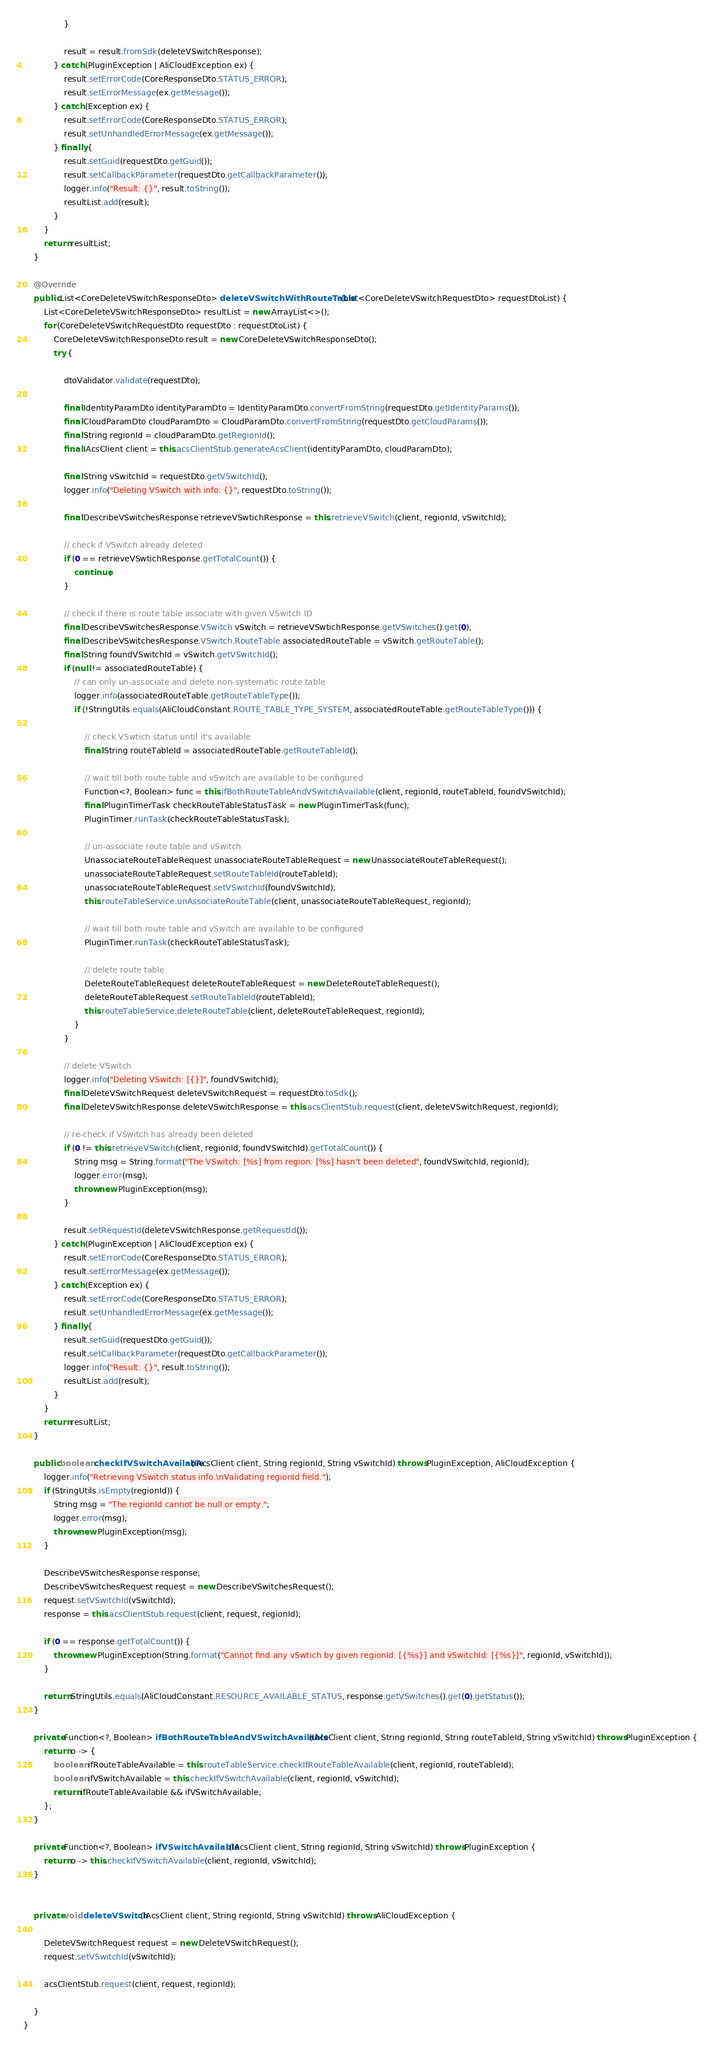<code> <loc_0><loc_0><loc_500><loc_500><_Java_>                }

                result = result.fromSdk(deleteVSwitchResponse);
            } catch (PluginException | AliCloudException ex) {
                result.setErrorCode(CoreResponseDto.STATUS_ERROR);
                result.setErrorMessage(ex.getMessage());
            } catch (Exception ex) {
                result.setErrorCode(CoreResponseDto.STATUS_ERROR);
                result.setUnhandledErrorMessage(ex.getMessage());
            } finally {
                result.setGuid(requestDto.getGuid());
                result.setCallbackParameter(requestDto.getCallbackParameter());
                logger.info("Result: {}", result.toString());
                resultList.add(result);
            }
        }
        return resultList;
    }

    @Override
    public List<CoreDeleteVSwitchResponseDto> deleteVSwitchWithRouteTable(List<CoreDeleteVSwitchRequestDto> requestDtoList) {
        List<CoreDeleteVSwitchResponseDto> resultList = new ArrayList<>();
        for (CoreDeleteVSwitchRequestDto requestDto : requestDtoList) {
            CoreDeleteVSwitchResponseDto result = new CoreDeleteVSwitchResponseDto();
            try {

                dtoValidator.validate(requestDto);

                final IdentityParamDto identityParamDto = IdentityParamDto.convertFromString(requestDto.getIdentityParams());
                final CloudParamDto cloudParamDto = CloudParamDto.convertFromString(requestDto.getCloudParams());
                final String regionId = cloudParamDto.getRegionId();
                final IAcsClient client = this.acsClientStub.generateAcsClient(identityParamDto, cloudParamDto);

                final String vSwitchId = requestDto.getVSwitchId();
                logger.info("Deleting VSwitch with info: {}", requestDto.toString());

                final DescribeVSwitchesResponse retrieveVSwtichResponse = this.retrieveVSwitch(client, regionId, vSwitchId);

                // check if VSwitch already deleted
                if (0 == retrieveVSwtichResponse.getTotalCount()) {
                    continue;
                }

                // check if there is route table associate with given VSwitch ID
                final DescribeVSwitchesResponse.VSwitch vSwitch = retrieveVSwtichResponse.getVSwitches().get(0);
                final DescribeVSwitchesResponse.VSwitch.RouteTable associatedRouteTable = vSwitch.getRouteTable();
                final String foundVSwitchId = vSwitch.getVSwitchId();
                if (null != associatedRouteTable) {
                    // can only un-associate and delete non-systematic route table
                    logger.info(associatedRouteTable.getRouteTableType());
                    if (!StringUtils.equals(AliCloudConstant.ROUTE_TABLE_TYPE_SYSTEM, associatedRouteTable.getRouteTableType())) {

                        // check VSwtich status until it's available
                        final String routeTableId = associatedRouteTable.getRouteTableId();

                        // wait till both route table and vSwitch are available to be configured
                        Function<?, Boolean> func = this.ifBothRouteTableAndVSwitchAvailable(client, regionId, routeTableId, foundVSwitchId);
                        final PluginTimerTask checkRouteTableStatusTask = new PluginTimerTask(func);
                        PluginTimer.runTask(checkRouteTableStatusTask);

                        // un-associate route table and vSwitch
                        UnassociateRouteTableRequest unassociateRouteTableRequest = new UnassociateRouteTableRequest();
                        unassociateRouteTableRequest.setRouteTableId(routeTableId);
                        unassociateRouteTableRequest.setVSwitchId(foundVSwitchId);
                        this.routeTableService.unAssociateRouteTable(client, unassociateRouteTableRequest, regionId);

                        // wait till both route table and vSwitch are available to be configured
                        PluginTimer.runTask(checkRouteTableStatusTask);

                        // delete route table
                        DeleteRouteTableRequest deleteRouteTableRequest = new DeleteRouteTableRequest();
                        deleteRouteTableRequest.setRouteTableId(routeTableId);
                        this.routeTableService.deleteRouteTable(client, deleteRouteTableRequest, regionId);
                    }
                }

                // delete VSwitch
                logger.info("Deleting VSwitch: [{}]", foundVSwitchId);
                final DeleteVSwitchRequest deleteVSwitchRequest = requestDto.toSdk();
                final DeleteVSwitchResponse deleteVSwitchResponse = this.acsClientStub.request(client, deleteVSwitchRequest, regionId);

                // re-check if VSwitch has already been deleted
                if (0 != this.retrieveVSwitch(client, regionId, foundVSwitchId).getTotalCount()) {
                    String msg = String.format("The VSwitch: [%s] from region: [%s] hasn't been deleted", foundVSwitchId, regionId);
                    logger.error(msg);
                    throw new PluginException(msg);
                }

                result.setRequestId(deleteVSwitchResponse.getRequestId());
            } catch (PluginException | AliCloudException ex) {
                result.setErrorCode(CoreResponseDto.STATUS_ERROR);
                result.setErrorMessage(ex.getMessage());
            } catch (Exception ex) {
                result.setErrorCode(CoreResponseDto.STATUS_ERROR);
                result.setUnhandledErrorMessage(ex.getMessage());
            } finally {
                result.setGuid(requestDto.getGuid());
                result.setCallbackParameter(requestDto.getCallbackParameter());
                logger.info("Result: {}", result.toString());
                resultList.add(result);
            }
        }
        return resultList;
    }

    public boolean checkIfVSwitchAvailable(IAcsClient client, String regionId, String vSwitchId) throws PluginException, AliCloudException {
        logger.info("Retrieving VSwitch status info.\nValidating regionId field.");
        if (StringUtils.isEmpty(regionId)) {
            String msg = "The regionId cannot be null or empty.";
            logger.error(msg);
            throw new PluginException(msg);
        }

        DescribeVSwitchesResponse response;
        DescribeVSwitchesRequest request = new DescribeVSwitchesRequest();
        request.setVSwitchId(vSwitchId);
        response = this.acsClientStub.request(client, request, regionId);

        if (0 == response.getTotalCount()) {
            throw new PluginException(String.format("Cannot find any vSwtich by given regionId: [{%s}] and vSwitchId: [{%s}]", regionId, vSwitchId));
        }

        return StringUtils.equals(AliCloudConstant.RESOURCE_AVAILABLE_STATUS, response.getVSwitches().get(0).getStatus());
    }

    private Function<?, Boolean> ifBothRouteTableAndVSwitchAvailable(IAcsClient client, String regionId, String routeTableId, String vSwitchId) throws PluginException {
        return o -> {
            boolean ifRouteTableAvailable = this.routeTableService.checkIfRouteTableAvailable(client, regionId, routeTableId);
            boolean ifVSwitchAvailable = this.checkIfVSwitchAvailable(client, regionId, vSwitchId);
            return ifRouteTableAvailable && ifVSwitchAvailable;
        };
    }

    private Function<?, Boolean> ifVSwitchAvailable(IAcsClient client, String regionId, String vSwitchId) throws PluginException {
        return o -> this.checkIfVSwitchAvailable(client, regionId, vSwitchId);
    }


    private void deleteVSwitch(IAcsClient client, String regionId, String vSwitchId) throws AliCloudException {

        DeleteVSwitchRequest request = new DeleteVSwitchRequest();
        request.setVSwitchId(vSwitchId);

        acsClientStub.request(client, request, regionId);

    }
}
</code> 